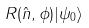<formula> <loc_0><loc_0><loc_500><loc_500>R ( \hat { n } , \phi ) | \psi _ { 0 } \rangle</formula> 